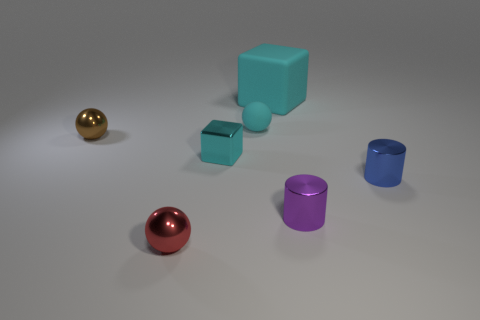Subtract all tiny cyan matte balls. How many balls are left? 2 Add 2 blue shiny cylinders. How many objects exist? 9 Subtract all red balls. How many balls are left? 2 Subtract 2 balls. How many balls are left? 1 Subtract all cylinders. How many objects are left? 5 Subtract all green cylinders. Subtract all purple balls. How many cylinders are left? 2 Subtract all small cyan blocks. Subtract all large cyan things. How many objects are left? 5 Add 5 small red objects. How many small red objects are left? 6 Add 2 tiny purple things. How many tiny purple things exist? 3 Subtract 0 gray spheres. How many objects are left? 7 